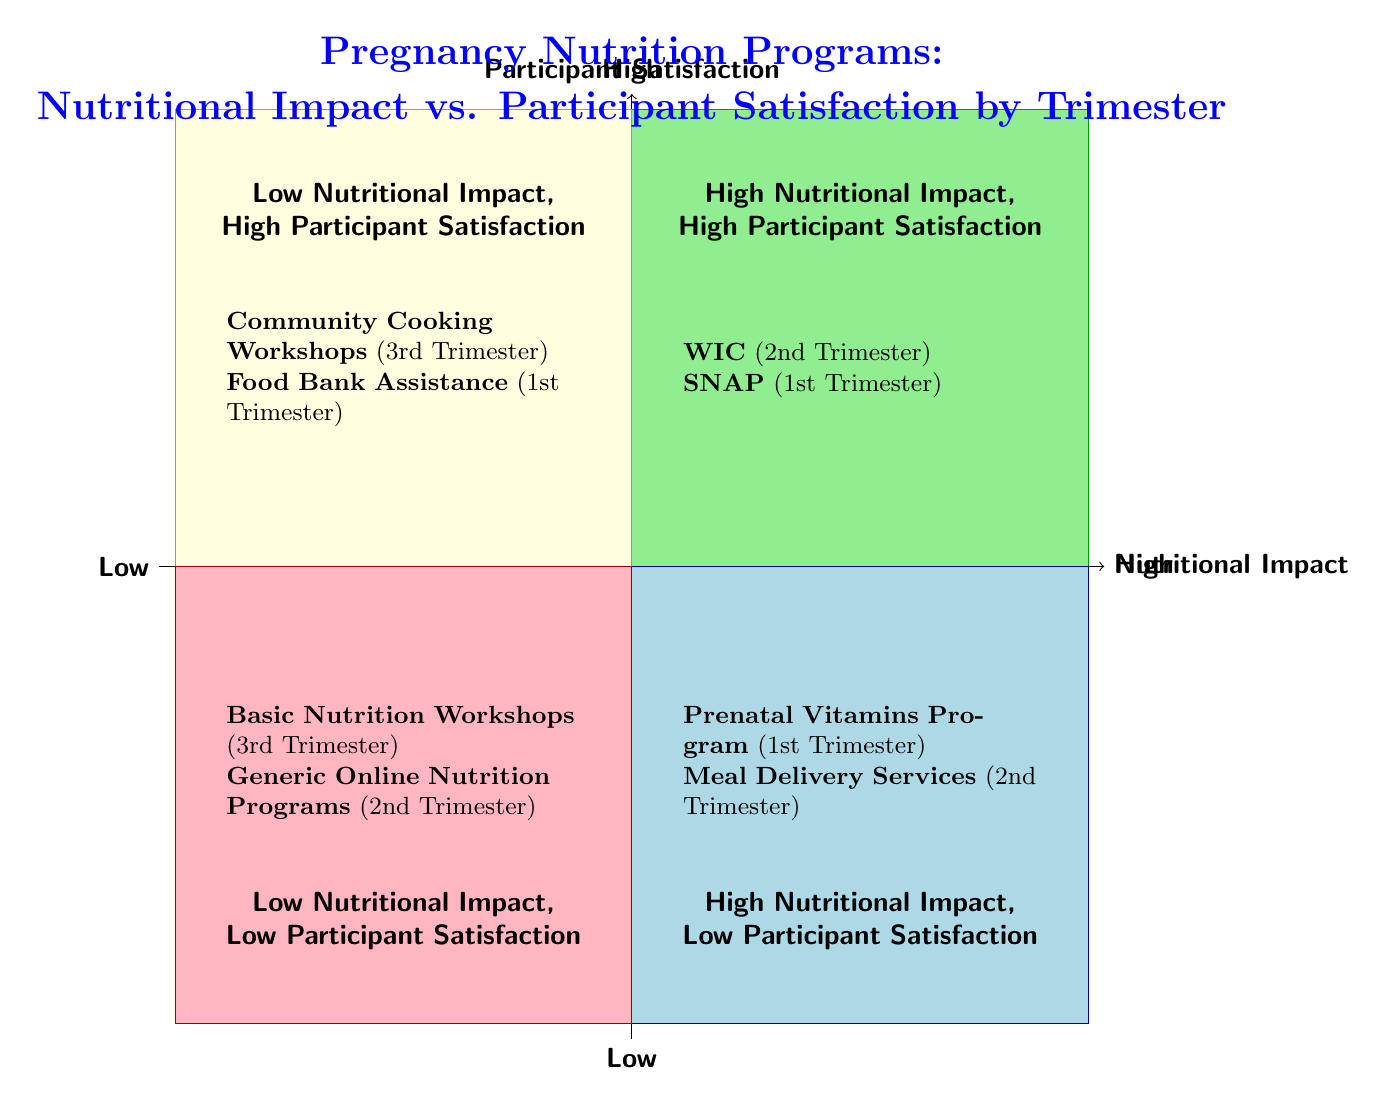What programs are in the "High Nutritional Impact, High Participant Satisfaction" quadrant? The "High Nutritional Impact, High Participant Satisfaction" quadrant includes the WIC program for the second trimester and the SNAP program for the first trimester.
Answer: WIC, SNAP What trimester is associated with the "Low Nutritional Impact, Low Participant Satisfaction" quadrant? The "Low Nutritional Impact, Low Participant Satisfaction" quadrant is associated with the third trimester as it contains the Basic Nutrition Workshops.
Answer: Third Trimester How many programs are listed in total in the diagram? There are a total of eight programs listed across the four quadrants in the diagram. Counting the examples in each quadrant gives us 8: 2 in each of the 4 quadrants.
Answer: 8 Which program provides essential nutrients in the "High Nutritional Impact, Low Participant Satisfaction" quadrant? The Meal Delivery Services program in the "High Nutritional Impact, Low Participant Satisfaction" quadrant offers tailored meal plans rich in essential nutrients.
Answer: Meal Delivery Services What is a common participant feedback for programs in the "Low Nutritional Impact, High Participant Satisfaction" quadrant? A common participant feedback in this quadrant is high satisfaction due to social interaction and skill development found in Community Cooking Workshops.
Answer: High satisfaction Why is satisfaction low for the Prenatal Vitamins Program? Satisfaction is low for the Prenatal Vitamins Program due to side effects like nausea reported by participants in the first trimester.
Answer: Side effects like nausea What does the "Generic Online Nutrition Programs" offer according to the diagram? The "Generic Online Nutrition Programs" provide limited impact due to non-specific guidelines, resulting in low satisfaction in the second trimester.
Answer: Limited impact Which quadrant contains a program that offers immediate availability of food? The "Low Nutritional Impact, High Participant Satisfaction" quadrant contains the Food Bank Assistance program, which is valued for immediate availability of food in the first trimester.
Answer: Low Nutritional Impact, High Participant Satisfaction What trimester is the WIC program targeted to? The WIC program is targeted to the second trimester, providing essential nutrients related to nutritional impact and participant satisfaction.
Answer: Second Trimester 